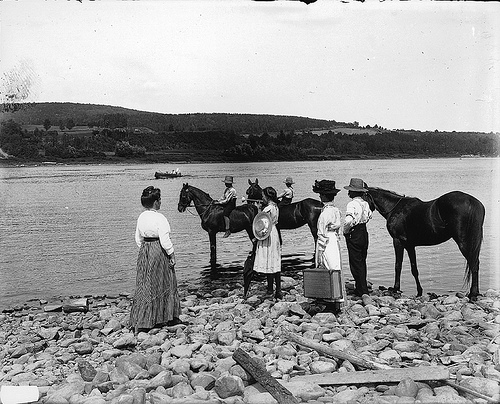What event is this? This photograph likely captures a river crossing or a rural outing from an earlier time period, suggested by the attire of the individuals and the presence of horses prepared to ford the river. Such events were common in rural communities as part of daily travel or special gatherings. 